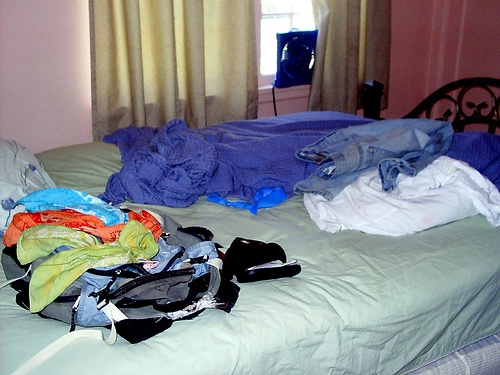Describe the objects in this image and their specific colors. I can see a bed in gray, darkgray, lightgray, blue, and black tones in this image. 